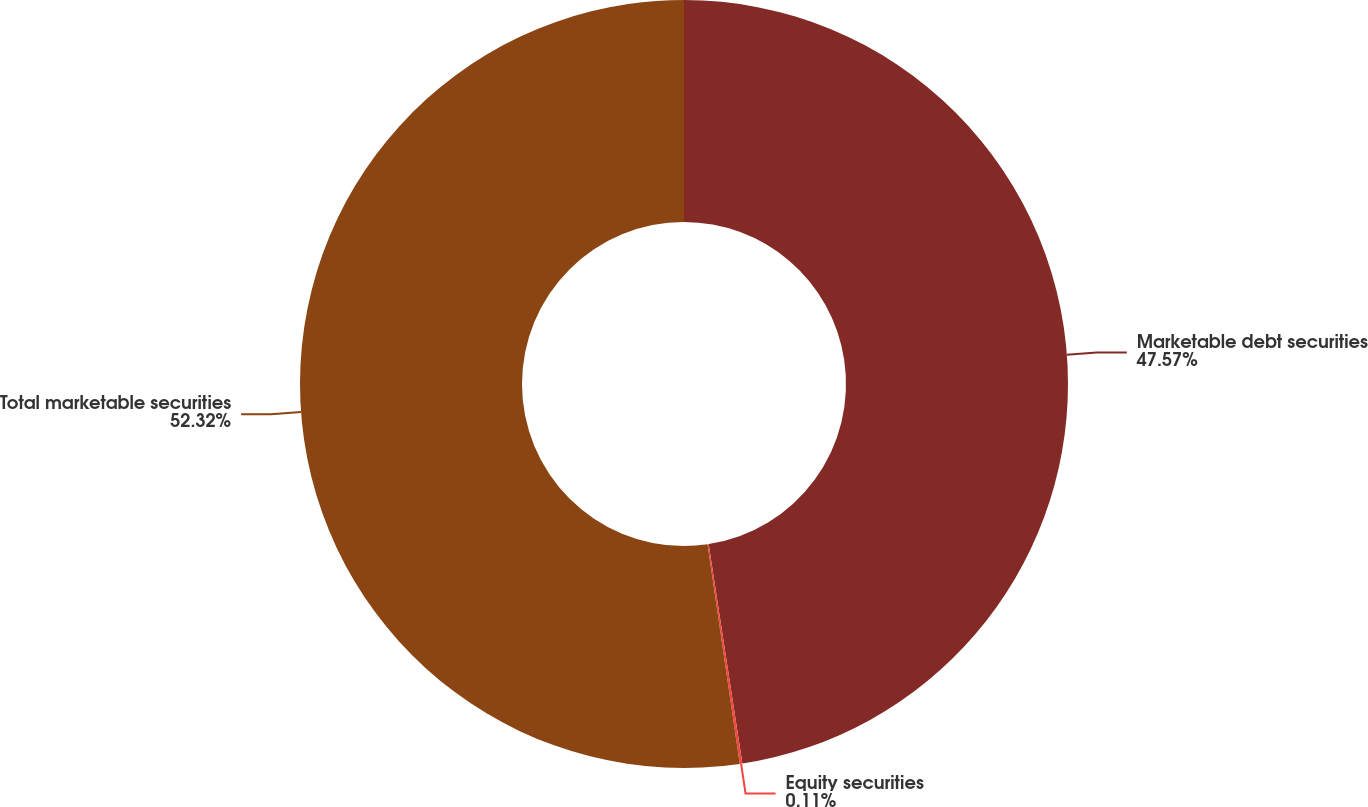Convert chart. <chart><loc_0><loc_0><loc_500><loc_500><pie_chart><fcel>Marketable debt securities<fcel>Equity securities<fcel>Total marketable securities<nl><fcel>47.57%<fcel>0.11%<fcel>52.32%<nl></chart> 